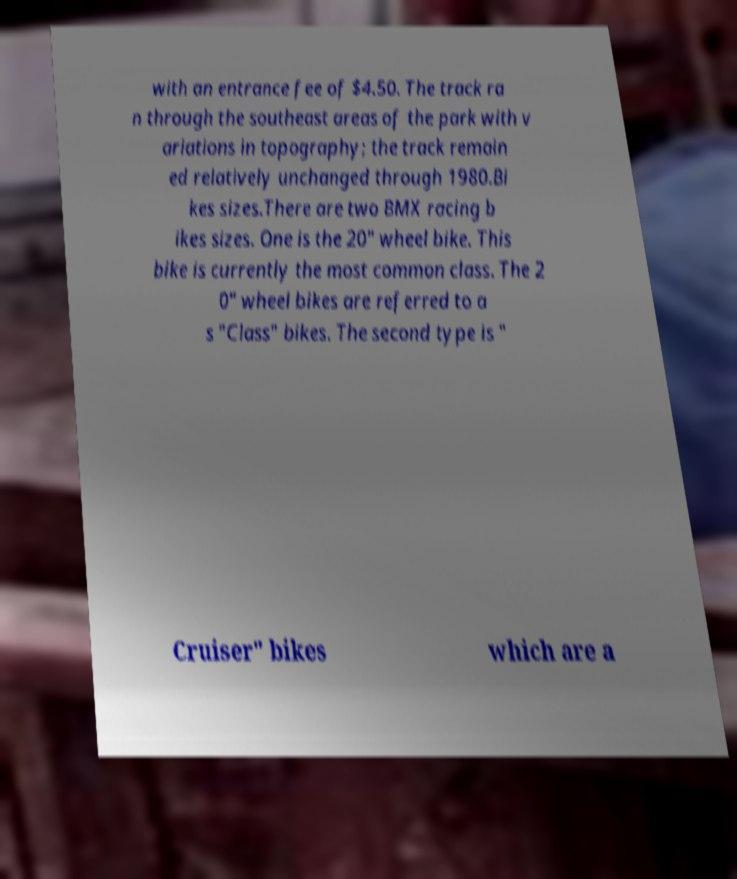Please identify and transcribe the text found in this image. with an entrance fee of $4.50. The track ra n through the southeast areas of the park with v ariations in topography; the track remain ed relatively unchanged through 1980.Bi kes sizes.There are two BMX racing b ikes sizes. One is the 20" wheel bike. This bike is currently the most common class. The 2 0" wheel bikes are referred to a s "Class" bikes. The second type is " Cruiser" bikes which are a 